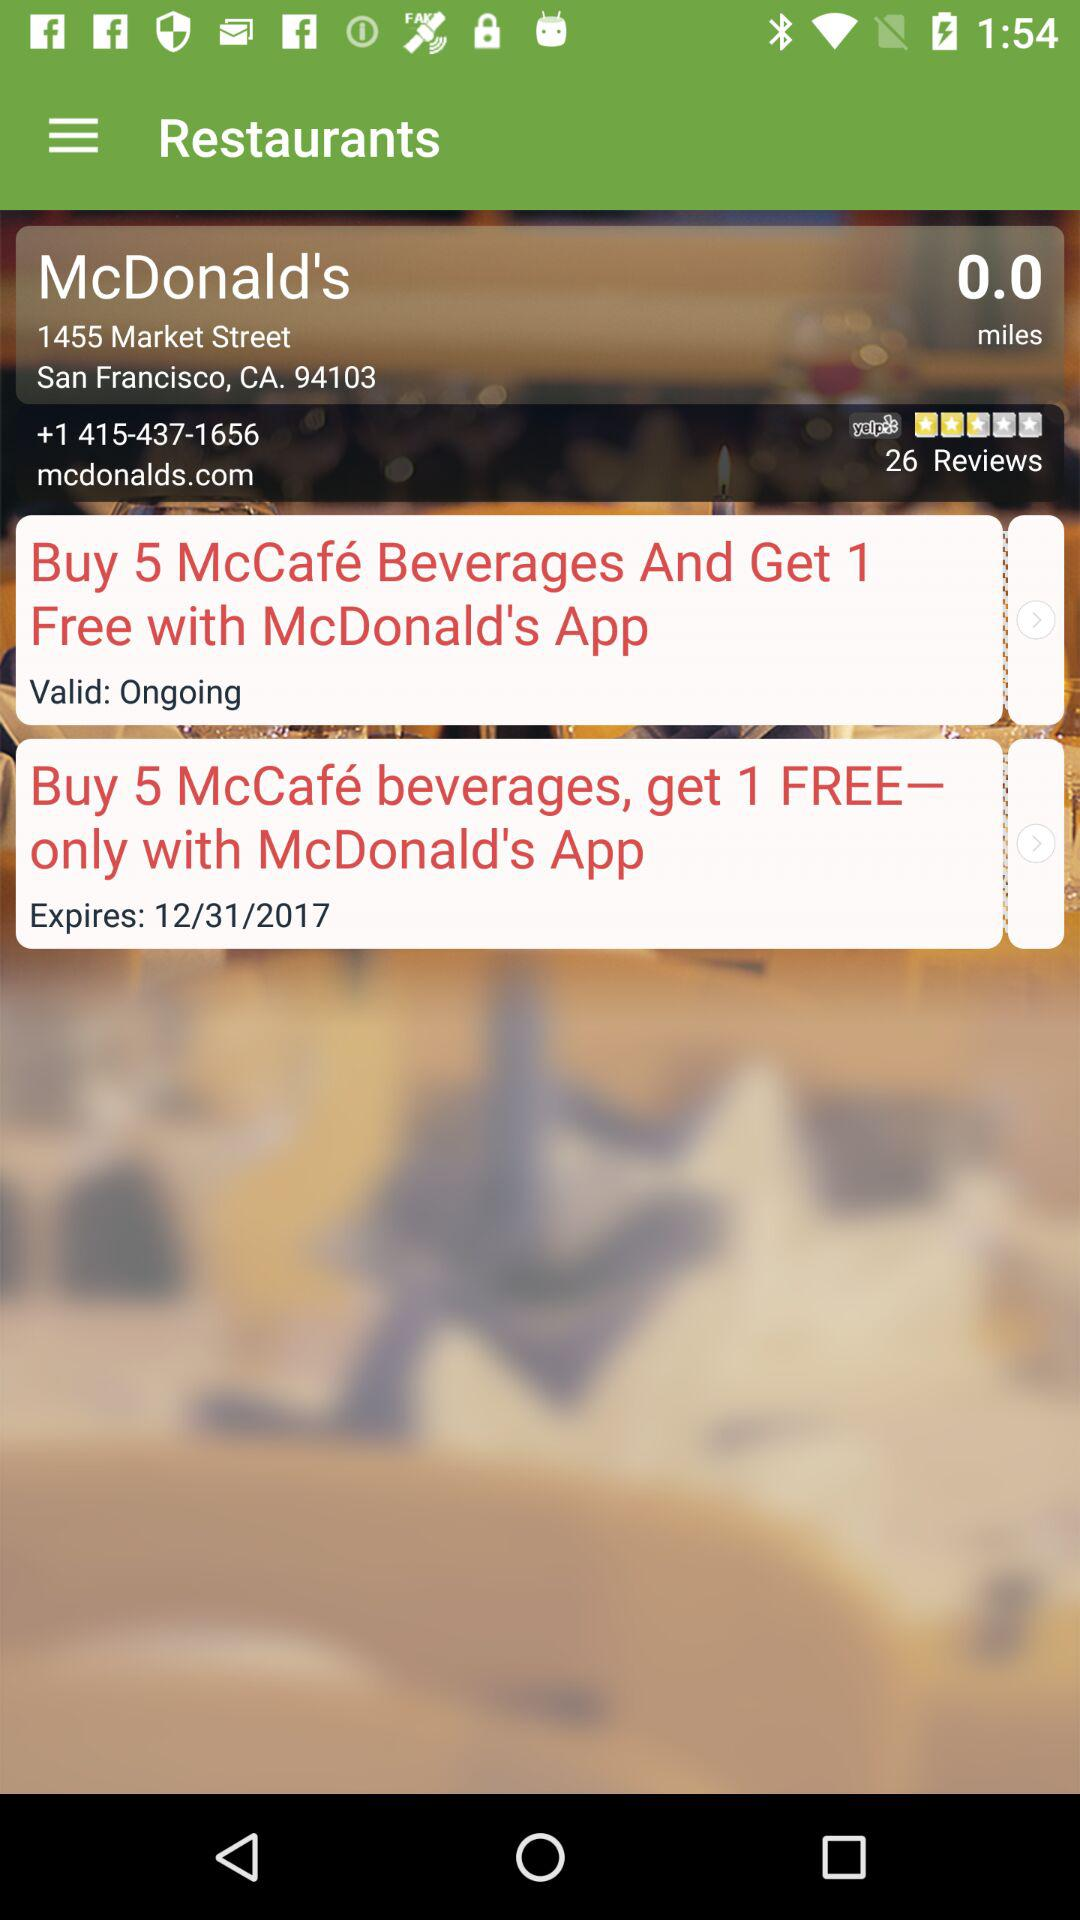What is the location? The location is 1455 Market Street, San Francisco, CA 94103. 